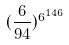Convert formula to latex. <formula><loc_0><loc_0><loc_500><loc_500>( \frac { 6 } { 9 4 } ) ^ { 6 ^ { 1 4 6 } }</formula> 